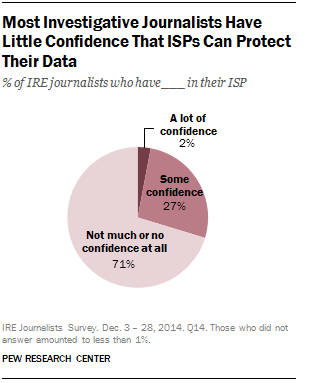Identify some key points in this picture. The smallest segment is equal to 2. The value of "Some Confidence" is not equal to half the value of the largest segment of the graph. 